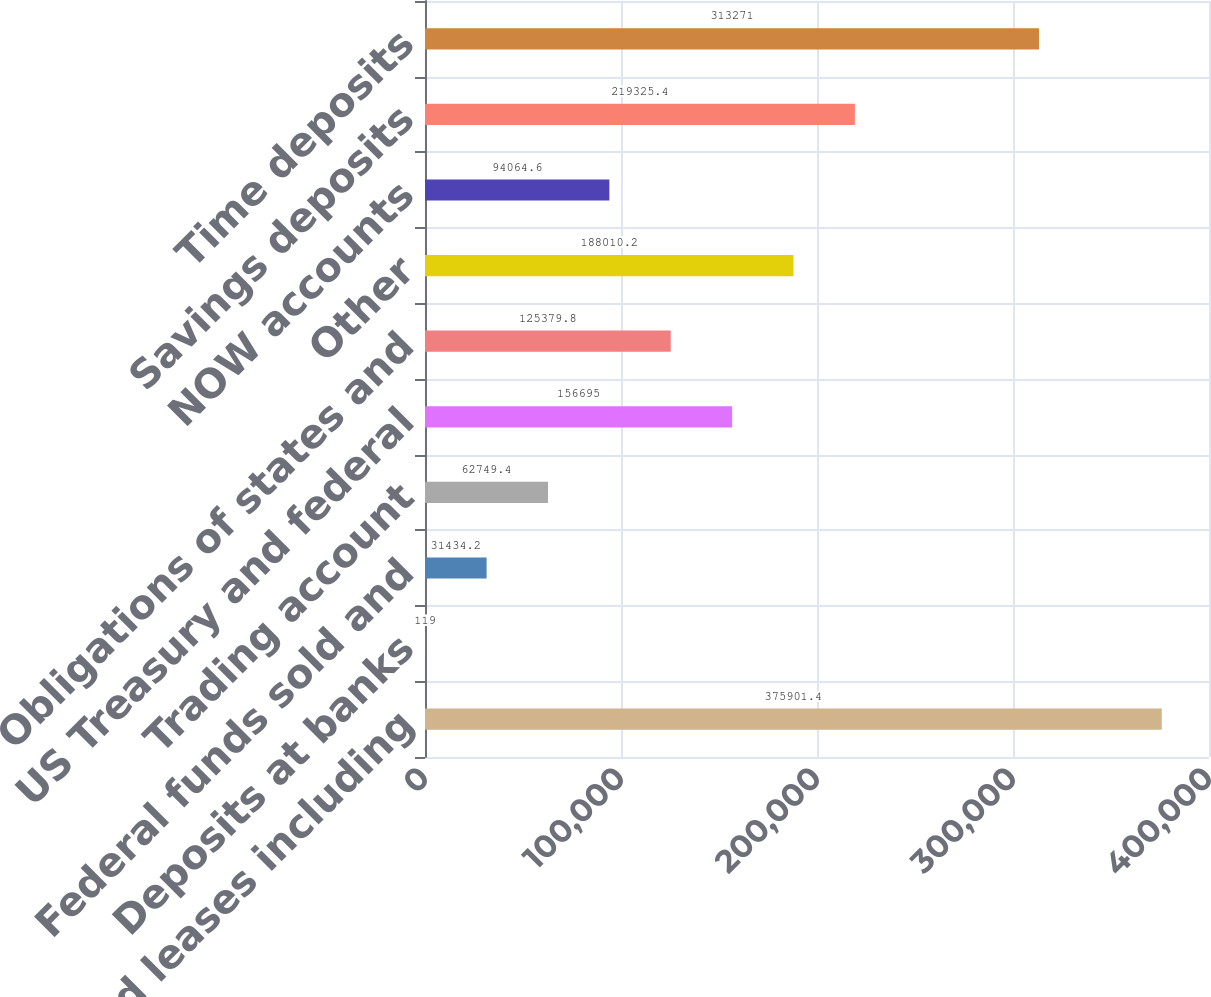Convert chart to OTSL. <chart><loc_0><loc_0><loc_500><loc_500><bar_chart><fcel>Loans and leases including<fcel>Deposits at banks<fcel>Federal funds sold and<fcel>Trading account<fcel>US Treasury and federal<fcel>Obligations of states and<fcel>Other<fcel>NOW accounts<fcel>Savings deposits<fcel>Time deposits<nl><fcel>375901<fcel>119<fcel>31434.2<fcel>62749.4<fcel>156695<fcel>125380<fcel>188010<fcel>94064.6<fcel>219325<fcel>313271<nl></chart> 